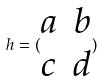<formula> <loc_0><loc_0><loc_500><loc_500>h = ( \begin{matrix} a & b \\ c & d \end{matrix} )</formula> 